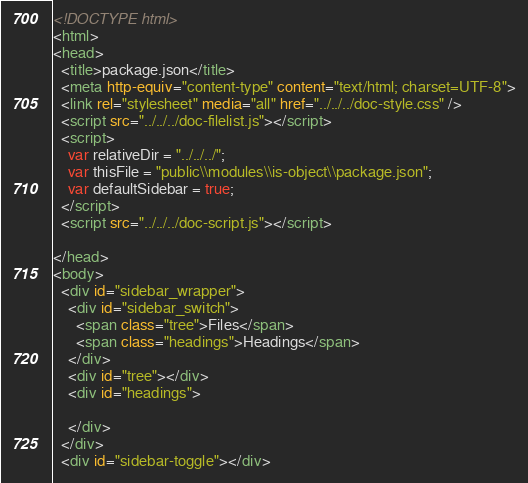Convert code to text. <code><loc_0><loc_0><loc_500><loc_500><_HTML_><!DOCTYPE html>
<html>
<head>
  <title>package.json</title>
  <meta http-equiv="content-type" content="text/html; charset=UTF-8">
  <link rel="stylesheet" media="all" href="../../../doc-style.css" />
  <script src="../../../doc-filelist.js"></script>
  <script>
    var relativeDir = "../../../";
    var thisFile = "public\\modules\\is-object\\package.json";
    var defaultSidebar = true;
  </script>
  <script src="../../../doc-script.js"></script>

</head>
<body>
  <div id="sidebar_wrapper">
    <div id="sidebar_switch">
      <span class="tree">Files</span>
      <span class="headings">Headings</span>
    </div>
    <div id="tree"></div>
    <div id="headings">

    </div>
  </div>
  <div id="sidebar-toggle"></div></code> 